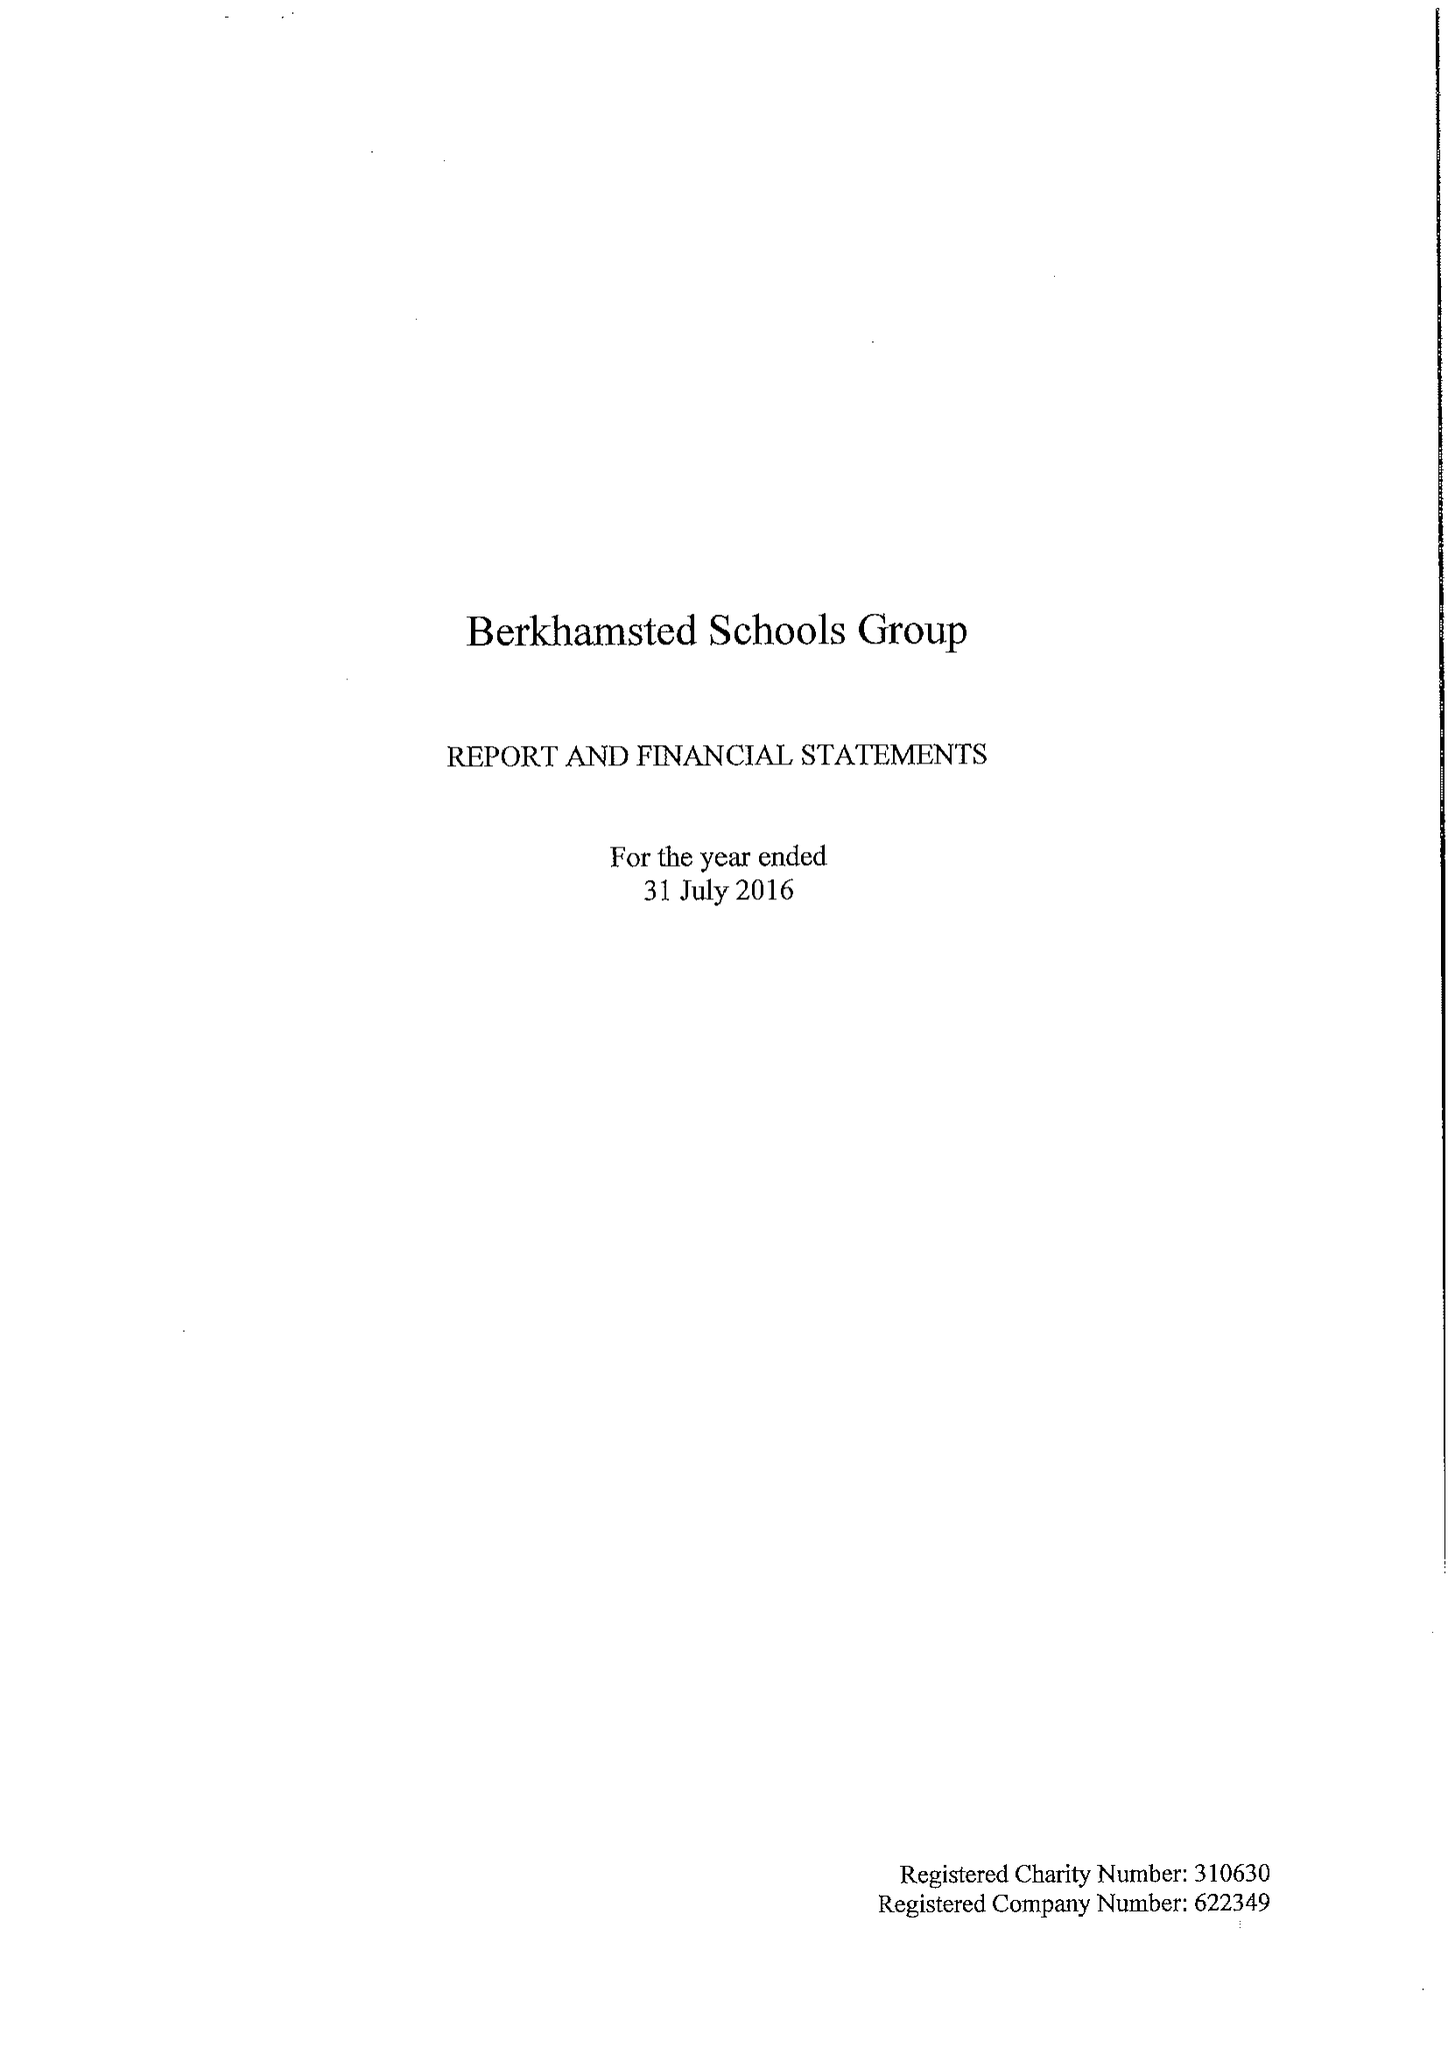What is the value for the charity_name?
Answer the question using a single word or phrase. Berkhamsted Schools Group 